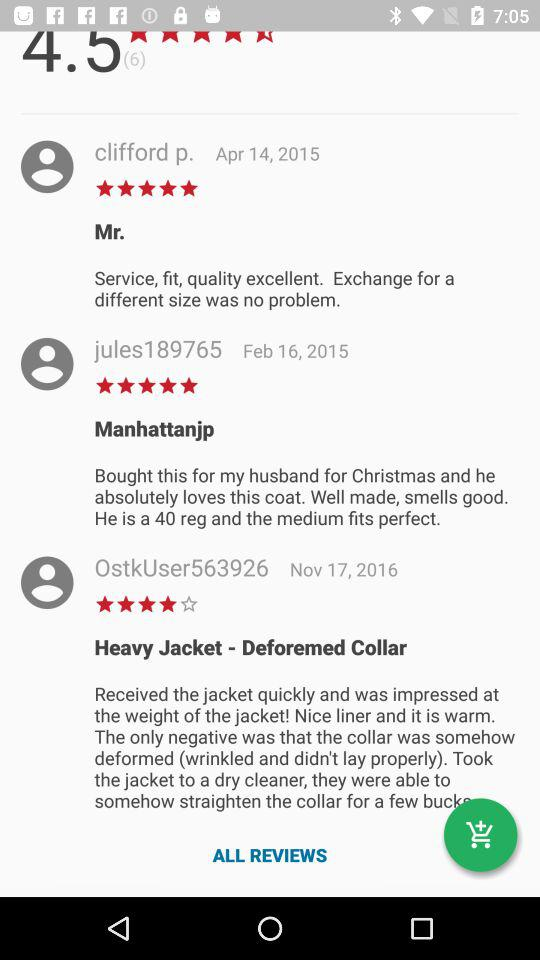What is the rating given by Clifford P.? The given rating is 5 stars. 